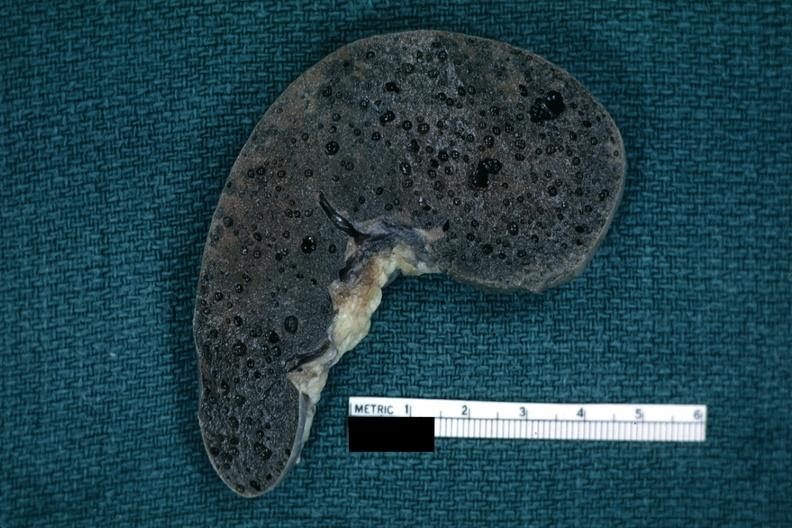what does this image show?
Answer the question using a single word or phrase. Fixed tissue typical swiss cheese appearance of tissue with artefact 